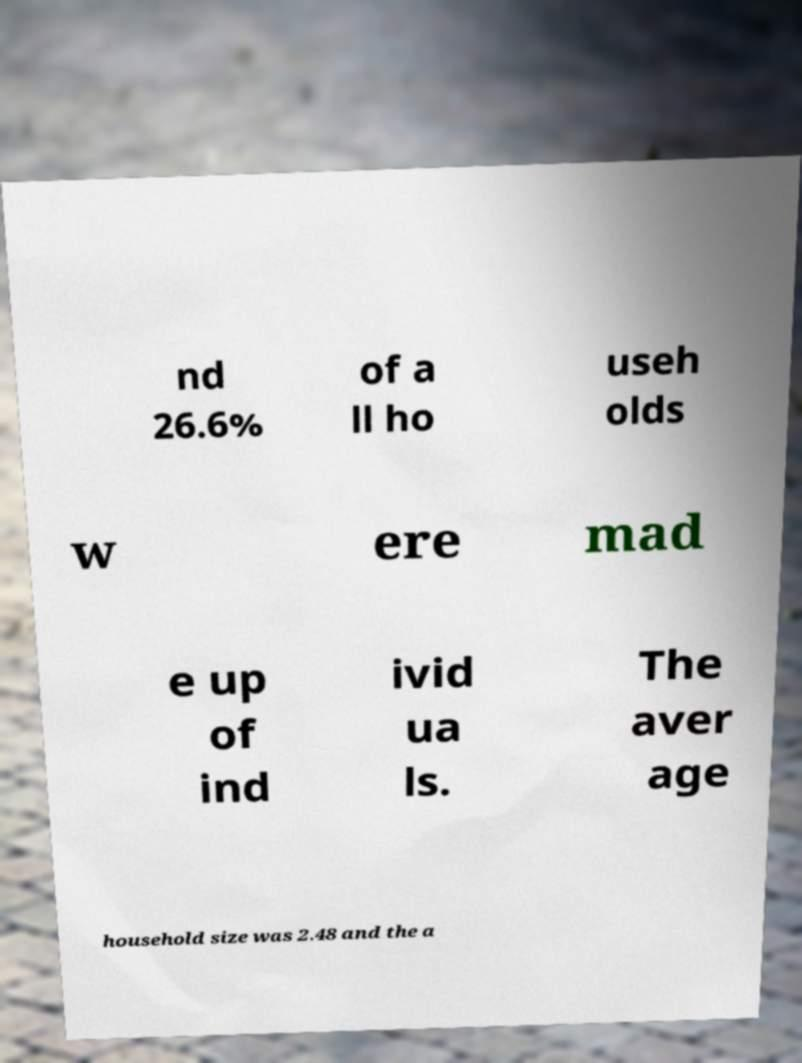There's text embedded in this image that I need extracted. Can you transcribe it verbatim? nd 26.6% of a ll ho useh olds w ere mad e up of ind ivid ua ls. The aver age household size was 2.48 and the a 